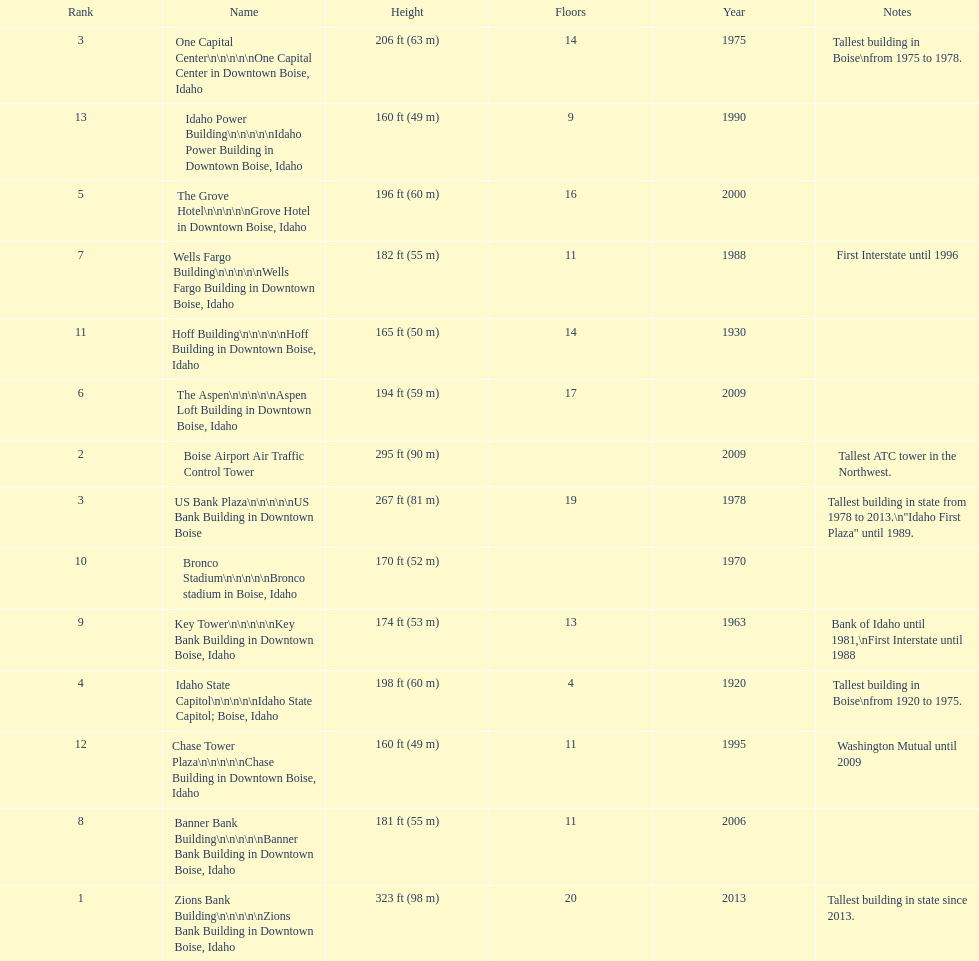What is the name of the last building on this chart? Idaho Power Building. 